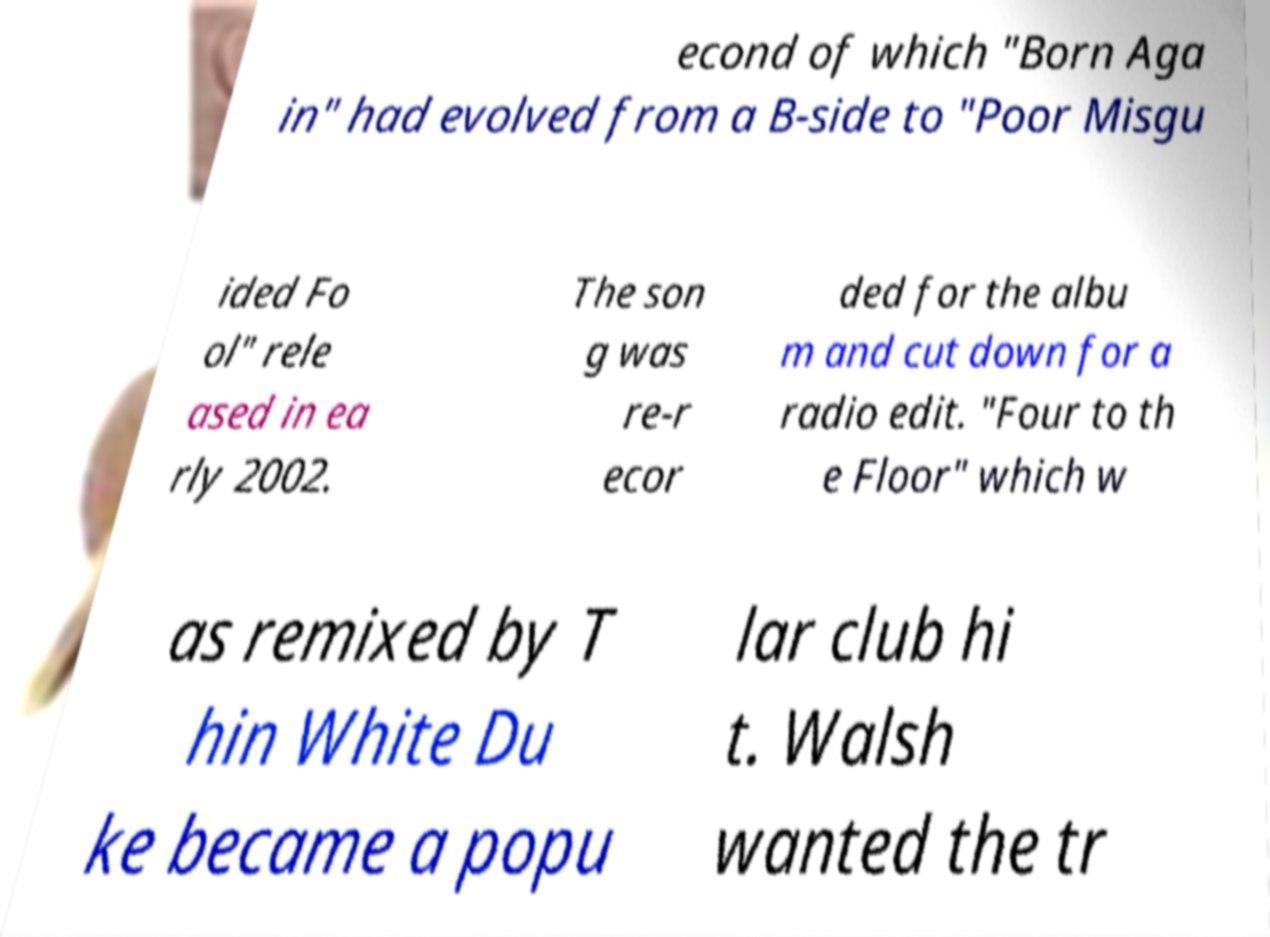I need the written content from this picture converted into text. Can you do that? econd of which "Born Aga in" had evolved from a B-side to "Poor Misgu ided Fo ol" rele ased in ea rly 2002. The son g was re-r ecor ded for the albu m and cut down for a radio edit. "Four to th e Floor" which w as remixed by T hin White Du ke became a popu lar club hi t. Walsh wanted the tr 